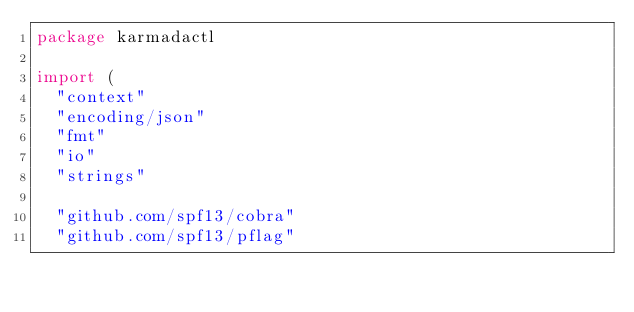Convert code to text. <code><loc_0><loc_0><loc_500><loc_500><_Go_>package karmadactl

import (
	"context"
	"encoding/json"
	"fmt"
	"io"
	"strings"

	"github.com/spf13/cobra"
	"github.com/spf13/pflag"</code> 